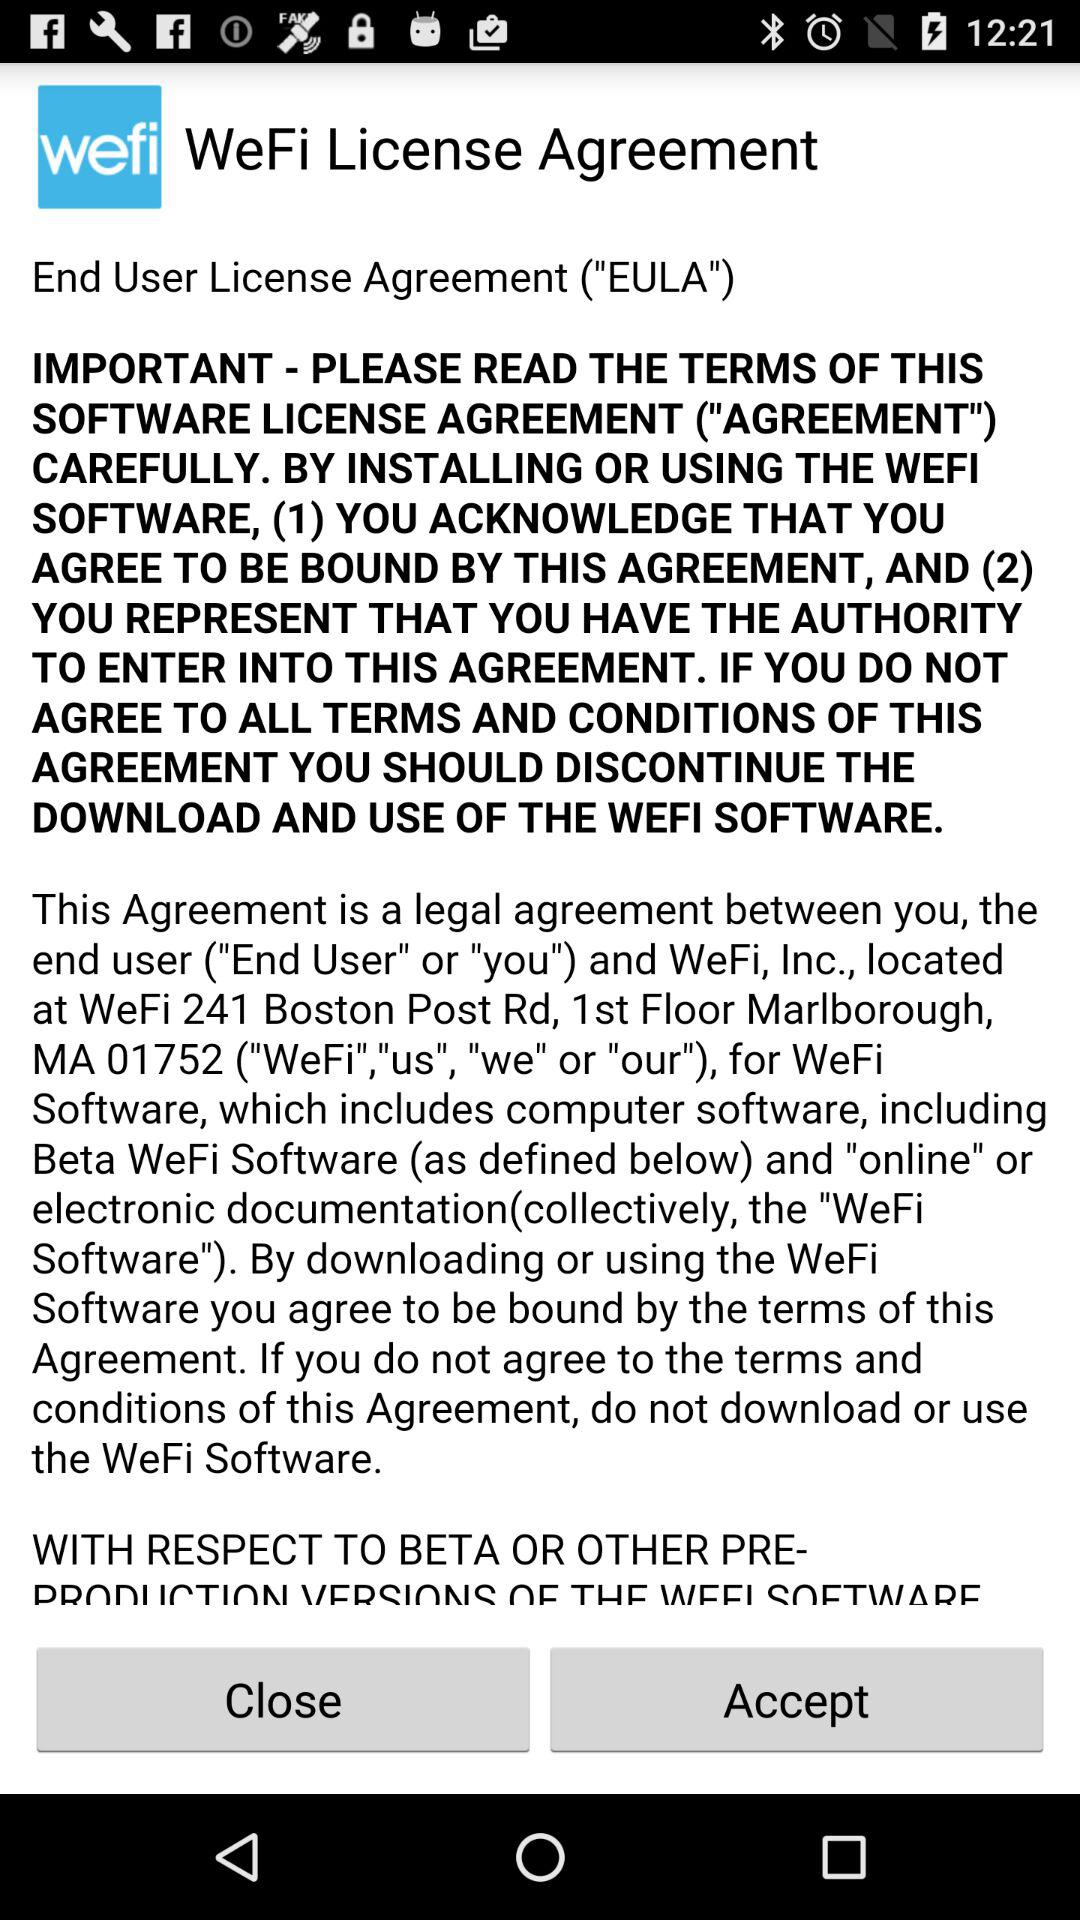What is the name of the application? The name of the application is "WeFi". 